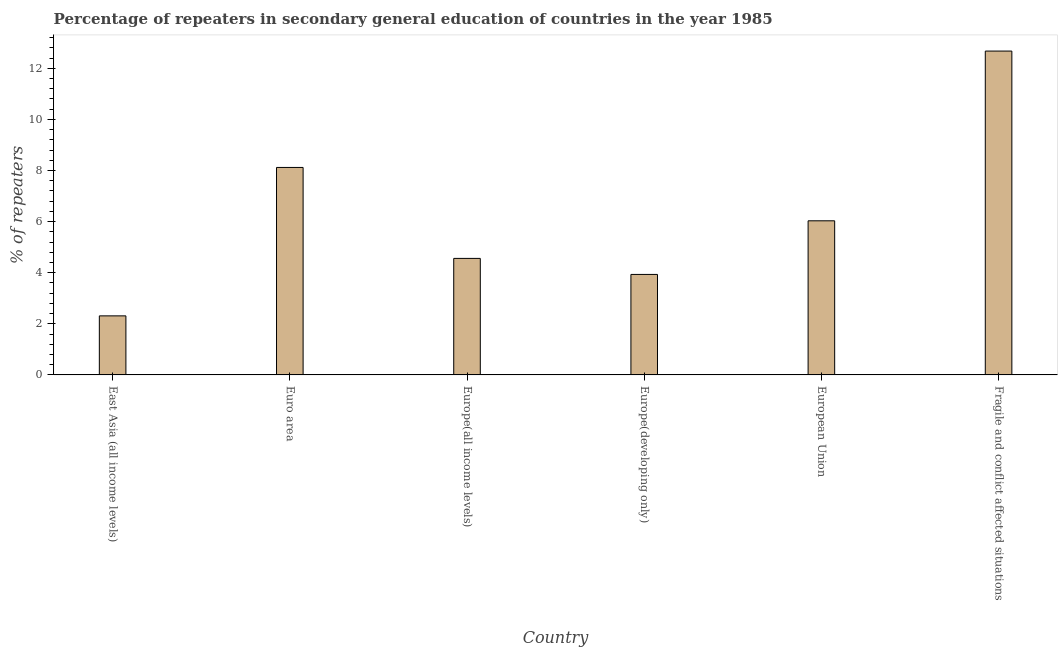Does the graph contain any zero values?
Ensure brevity in your answer.  No. What is the title of the graph?
Give a very brief answer. Percentage of repeaters in secondary general education of countries in the year 1985. What is the label or title of the Y-axis?
Ensure brevity in your answer.  % of repeaters. What is the percentage of repeaters in Euro area?
Provide a short and direct response. 8.12. Across all countries, what is the maximum percentage of repeaters?
Your response must be concise. 12.67. Across all countries, what is the minimum percentage of repeaters?
Keep it short and to the point. 2.31. In which country was the percentage of repeaters maximum?
Your answer should be compact. Fragile and conflict affected situations. In which country was the percentage of repeaters minimum?
Keep it short and to the point. East Asia (all income levels). What is the sum of the percentage of repeaters?
Provide a succinct answer. 37.62. What is the difference between the percentage of repeaters in East Asia (all income levels) and Europe(all income levels)?
Ensure brevity in your answer.  -2.25. What is the average percentage of repeaters per country?
Provide a succinct answer. 6.27. What is the median percentage of repeaters?
Your answer should be very brief. 5.29. What is the ratio of the percentage of repeaters in East Asia (all income levels) to that in Euro area?
Provide a short and direct response. 0.28. Is the percentage of repeaters in Euro area less than that in European Union?
Keep it short and to the point. No. Is the difference between the percentage of repeaters in Euro area and Europe(all income levels) greater than the difference between any two countries?
Keep it short and to the point. No. What is the difference between the highest and the second highest percentage of repeaters?
Your answer should be compact. 4.55. Is the sum of the percentage of repeaters in Europe(developing only) and European Union greater than the maximum percentage of repeaters across all countries?
Ensure brevity in your answer.  No. What is the difference between the highest and the lowest percentage of repeaters?
Offer a terse response. 10.36. In how many countries, is the percentage of repeaters greater than the average percentage of repeaters taken over all countries?
Make the answer very short. 2. How many countries are there in the graph?
Give a very brief answer. 6. What is the difference between two consecutive major ticks on the Y-axis?
Offer a very short reply. 2. What is the % of repeaters of East Asia (all income levels)?
Your answer should be very brief. 2.31. What is the % of repeaters of Euro area?
Offer a terse response. 8.12. What is the % of repeaters of Europe(all income levels)?
Provide a succinct answer. 4.56. What is the % of repeaters in Europe(developing only)?
Your answer should be very brief. 3.93. What is the % of repeaters in European Union?
Provide a short and direct response. 6.03. What is the % of repeaters of Fragile and conflict affected situations?
Offer a very short reply. 12.67. What is the difference between the % of repeaters in East Asia (all income levels) and Euro area?
Keep it short and to the point. -5.81. What is the difference between the % of repeaters in East Asia (all income levels) and Europe(all income levels)?
Make the answer very short. -2.25. What is the difference between the % of repeaters in East Asia (all income levels) and Europe(developing only)?
Keep it short and to the point. -1.62. What is the difference between the % of repeaters in East Asia (all income levels) and European Union?
Keep it short and to the point. -3.72. What is the difference between the % of repeaters in East Asia (all income levels) and Fragile and conflict affected situations?
Your answer should be compact. -10.36. What is the difference between the % of repeaters in Euro area and Europe(all income levels)?
Provide a short and direct response. 3.56. What is the difference between the % of repeaters in Euro area and Europe(developing only)?
Your response must be concise. 4.19. What is the difference between the % of repeaters in Euro area and European Union?
Your response must be concise. 2.09. What is the difference between the % of repeaters in Euro area and Fragile and conflict affected situations?
Your response must be concise. -4.55. What is the difference between the % of repeaters in Europe(all income levels) and Europe(developing only)?
Offer a very short reply. 0.63. What is the difference between the % of repeaters in Europe(all income levels) and European Union?
Give a very brief answer. -1.47. What is the difference between the % of repeaters in Europe(all income levels) and Fragile and conflict affected situations?
Keep it short and to the point. -8.11. What is the difference between the % of repeaters in Europe(developing only) and European Union?
Ensure brevity in your answer.  -2.1. What is the difference between the % of repeaters in Europe(developing only) and Fragile and conflict affected situations?
Provide a succinct answer. -8.74. What is the difference between the % of repeaters in European Union and Fragile and conflict affected situations?
Provide a short and direct response. -6.64. What is the ratio of the % of repeaters in East Asia (all income levels) to that in Euro area?
Your response must be concise. 0.28. What is the ratio of the % of repeaters in East Asia (all income levels) to that in Europe(all income levels)?
Give a very brief answer. 0.51. What is the ratio of the % of repeaters in East Asia (all income levels) to that in Europe(developing only)?
Provide a succinct answer. 0.59. What is the ratio of the % of repeaters in East Asia (all income levels) to that in European Union?
Keep it short and to the point. 0.38. What is the ratio of the % of repeaters in East Asia (all income levels) to that in Fragile and conflict affected situations?
Provide a short and direct response. 0.18. What is the ratio of the % of repeaters in Euro area to that in Europe(all income levels)?
Keep it short and to the point. 1.78. What is the ratio of the % of repeaters in Euro area to that in Europe(developing only)?
Your response must be concise. 2.06. What is the ratio of the % of repeaters in Euro area to that in European Union?
Provide a succinct answer. 1.35. What is the ratio of the % of repeaters in Euro area to that in Fragile and conflict affected situations?
Provide a short and direct response. 0.64. What is the ratio of the % of repeaters in Europe(all income levels) to that in Europe(developing only)?
Your response must be concise. 1.16. What is the ratio of the % of repeaters in Europe(all income levels) to that in European Union?
Keep it short and to the point. 0.76. What is the ratio of the % of repeaters in Europe(all income levels) to that in Fragile and conflict affected situations?
Keep it short and to the point. 0.36. What is the ratio of the % of repeaters in Europe(developing only) to that in European Union?
Your answer should be very brief. 0.65. What is the ratio of the % of repeaters in Europe(developing only) to that in Fragile and conflict affected situations?
Give a very brief answer. 0.31. What is the ratio of the % of repeaters in European Union to that in Fragile and conflict affected situations?
Ensure brevity in your answer.  0.48. 